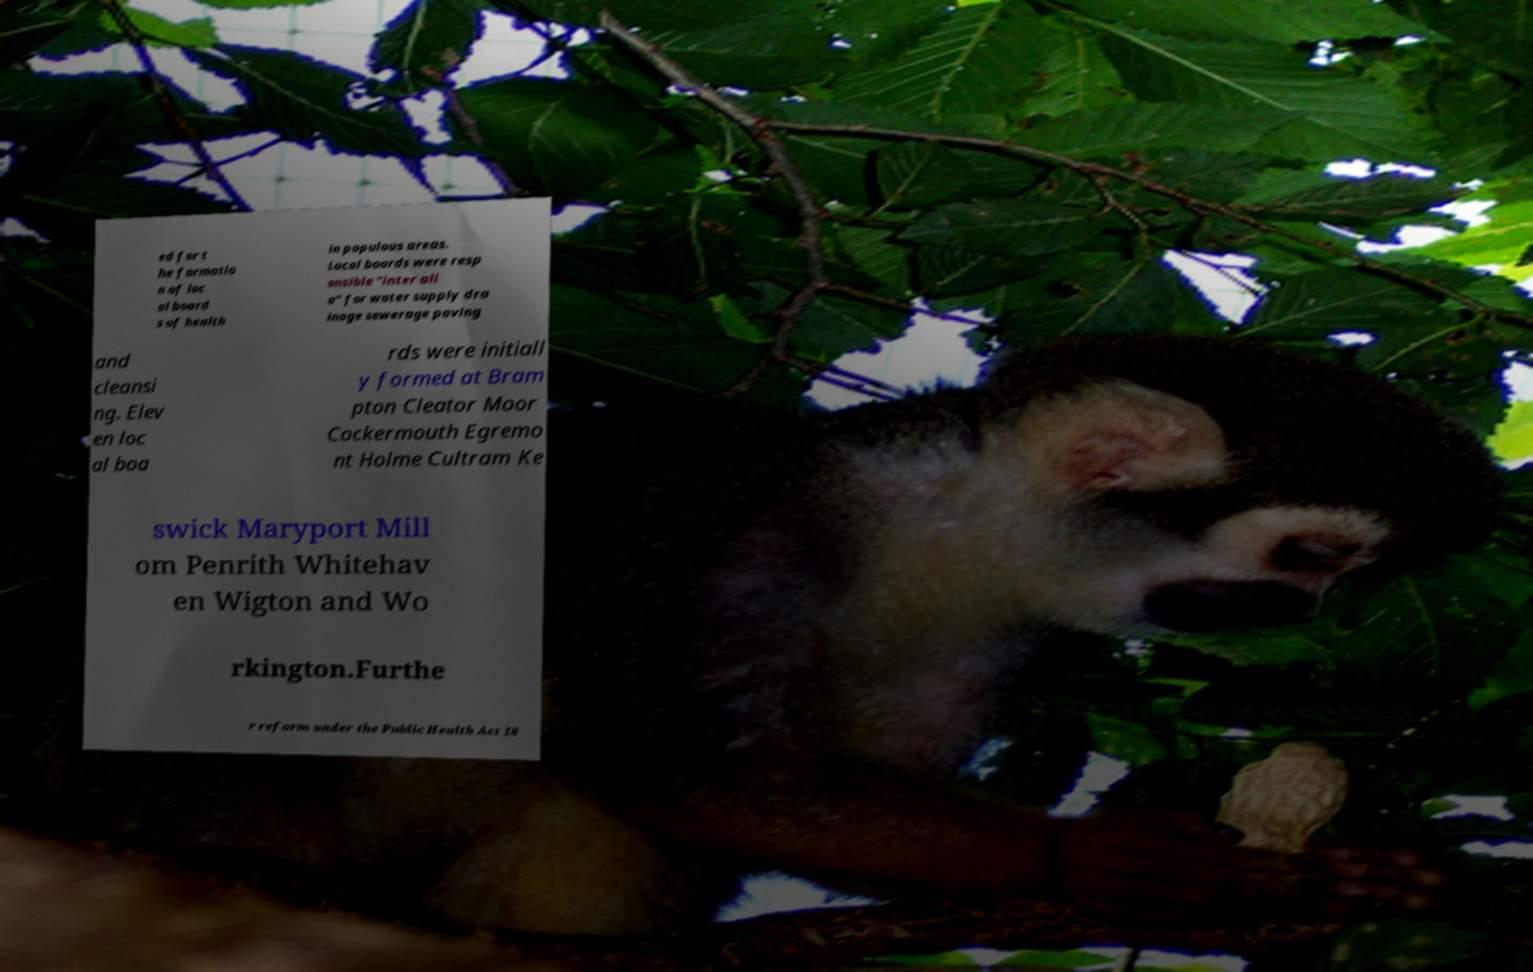For documentation purposes, I need the text within this image transcribed. Could you provide that? ed for t he formatio n of loc al board s of health in populous areas. Local boards were resp onsible "inter ali a" for water supply dra inage sewerage paving and cleansi ng. Elev en loc al boa rds were initiall y formed at Bram pton Cleator Moor Cockermouth Egremo nt Holme Cultram Ke swick Maryport Mill om Penrith Whitehav en Wigton and Wo rkington.Furthe r reform under the Public Health Act 18 